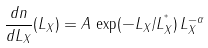<formula> <loc_0><loc_0><loc_500><loc_500>\frac { d n } { d L _ { X } } ( L _ { X } ) = A \, \exp ( - L _ { X } / L _ { X } ^ { ^ { * } } ) \, L _ { X } ^ { - \alpha }</formula> 